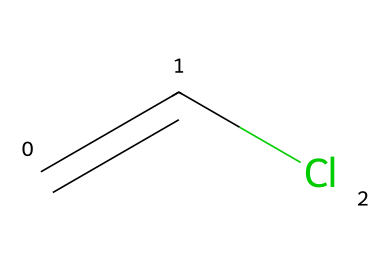What is the name of this chemical? The SMILES representation provided corresponds to vinyl chloride, which is widely recognized as a key monomer in the production of polyvinyl chloride (PVC).
Answer: vinyl chloride How many carbon atoms are present in the structure? The SMILES indicates two carbon atoms are linked together by a double bond, represented by "C=C." Thus, there are two carbon atoms total in the structure.
Answer: 2 What type of bond connects the carbon atoms? The "C=C" in the SMILES representation indicates a double bond between the two carbon atoms. A double bond consists of one sigma bond and one pi bond, indicating strong connectivity in the structure.
Answer: double bond How many chlorine atoms are attached to the carbon structure? The "Cl" in the SMILES representation signifies that there is one chlorine atom attached to one of the carbon atoms in the vinyl chloride structure.
Answer: 1 What unique feature of vinyl chloride contributes to its polymerization? The presence of the double bond "C=C" in the structure is a key feature that allows vinyl chloride to undergo addition polymerization, leading to the formation of PVC. The reactive nature of the double bond facilitates this process.
Answer: double bond Is vinyl chloride a solid, liquid, or gas at room temperature? Vinyl chloride is a gaseous compound at room temperature, typically existing as a colorless gas that can be easily compressed and transformed into a liquid under pressure.
Answer: gas 